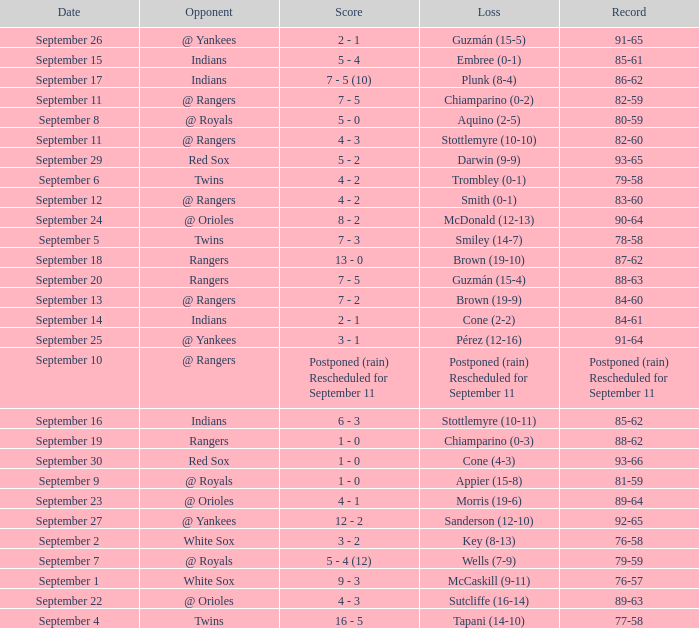What opponent has a loss of McCaskill (9-11)? White Sox. 